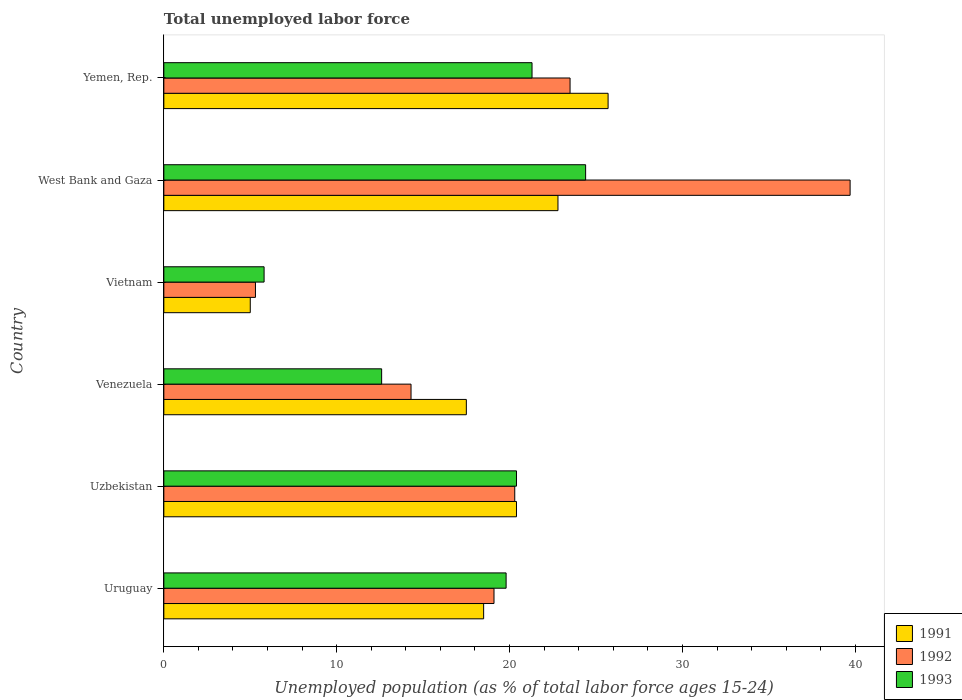How many groups of bars are there?
Make the answer very short. 6. Are the number of bars per tick equal to the number of legend labels?
Offer a terse response. Yes. How many bars are there on the 1st tick from the bottom?
Your response must be concise. 3. What is the label of the 2nd group of bars from the top?
Your response must be concise. West Bank and Gaza. What is the percentage of unemployed population in in 1993 in Vietnam?
Ensure brevity in your answer.  5.8. Across all countries, what is the maximum percentage of unemployed population in in 1992?
Give a very brief answer. 39.7. Across all countries, what is the minimum percentage of unemployed population in in 1992?
Give a very brief answer. 5.3. In which country was the percentage of unemployed population in in 1992 maximum?
Provide a succinct answer. West Bank and Gaza. In which country was the percentage of unemployed population in in 1993 minimum?
Offer a very short reply. Vietnam. What is the total percentage of unemployed population in in 1993 in the graph?
Provide a succinct answer. 104.3. What is the difference between the percentage of unemployed population in in 1991 in Uzbekistan and that in Venezuela?
Provide a succinct answer. 2.9. What is the difference between the percentage of unemployed population in in 1993 in West Bank and Gaza and the percentage of unemployed population in in 1992 in Venezuela?
Provide a short and direct response. 10.1. What is the average percentage of unemployed population in in 1993 per country?
Make the answer very short. 17.38. What is the difference between the percentage of unemployed population in in 1993 and percentage of unemployed population in in 1991 in Uzbekistan?
Make the answer very short. 0. In how many countries, is the percentage of unemployed population in in 1992 greater than 38 %?
Your response must be concise. 1. What is the ratio of the percentage of unemployed population in in 1992 in Vietnam to that in West Bank and Gaza?
Provide a short and direct response. 0.13. Is the percentage of unemployed population in in 1993 in Vietnam less than that in Yemen, Rep.?
Offer a terse response. Yes. What is the difference between the highest and the second highest percentage of unemployed population in in 1991?
Keep it short and to the point. 2.9. What is the difference between the highest and the lowest percentage of unemployed population in in 1991?
Your response must be concise. 20.7. Is the sum of the percentage of unemployed population in in 1992 in Uzbekistan and Vietnam greater than the maximum percentage of unemployed population in in 1991 across all countries?
Give a very brief answer. No. What does the 1st bar from the bottom in Vietnam represents?
Provide a succinct answer. 1991. Is it the case that in every country, the sum of the percentage of unemployed population in in 1993 and percentage of unemployed population in in 1991 is greater than the percentage of unemployed population in in 1992?
Give a very brief answer. Yes. How many bars are there?
Your response must be concise. 18. How many countries are there in the graph?
Ensure brevity in your answer.  6. What is the difference between two consecutive major ticks on the X-axis?
Your answer should be very brief. 10. Are the values on the major ticks of X-axis written in scientific E-notation?
Offer a very short reply. No. Does the graph contain grids?
Your answer should be very brief. No. How many legend labels are there?
Provide a succinct answer. 3. How are the legend labels stacked?
Ensure brevity in your answer.  Vertical. What is the title of the graph?
Provide a succinct answer. Total unemployed labor force. Does "1969" appear as one of the legend labels in the graph?
Make the answer very short. No. What is the label or title of the X-axis?
Provide a succinct answer. Unemployed population (as % of total labor force ages 15-24). What is the Unemployed population (as % of total labor force ages 15-24) of 1991 in Uruguay?
Provide a succinct answer. 18.5. What is the Unemployed population (as % of total labor force ages 15-24) of 1992 in Uruguay?
Offer a terse response. 19.1. What is the Unemployed population (as % of total labor force ages 15-24) in 1993 in Uruguay?
Give a very brief answer. 19.8. What is the Unemployed population (as % of total labor force ages 15-24) in 1991 in Uzbekistan?
Provide a succinct answer. 20.4. What is the Unemployed population (as % of total labor force ages 15-24) in 1992 in Uzbekistan?
Your answer should be very brief. 20.3. What is the Unemployed population (as % of total labor force ages 15-24) in 1993 in Uzbekistan?
Offer a very short reply. 20.4. What is the Unemployed population (as % of total labor force ages 15-24) of 1992 in Venezuela?
Your answer should be compact. 14.3. What is the Unemployed population (as % of total labor force ages 15-24) in 1993 in Venezuela?
Your answer should be very brief. 12.6. What is the Unemployed population (as % of total labor force ages 15-24) of 1991 in Vietnam?
Your answer should be compact. 5. What is the Unemployed population (as % of total labor force ages 15-24) of 1992 in Vietnam?
Your answer should be compact. 5.3. What is the Unemployed population (as % of total labor force ages 15-24) of 1993 in Vietnam?
Your answer should be compact. 5.8. What is the Unemployed population (as % of total labor force ages 15-24) of 1991 in West Bank and Gaza?
Keep it short and to the point. 22.8. What is the Unemployed population (as % of total labor force ages 15-24) of 1992 in West Bank and Gaza?
Your response must be concise. 39.7. What is the Unemployed population (as % of total labor force ages 15-24) of 1993 in West Bank and Gaza?
Ensure brevity in your answer.  24.4. What is the Unemployed population (as % of total labor force ages 15-24) of 1991 in Yemen, Rep.?
Offer a terse response. 25.7. What is the Unemployed population (as % of total labor force ages 15-24) of 1993 in Yemen, Rep.?
Keep it short and to the point. 21.3. Across all countries, what is the maximum Unemployed population (as % of total labor force ages 15-24) of 1991?
Ensure brevity in your answer.  25.7. Across all countries, what is the maximum Unemployed population (as % of total labor force ages 15-24) in 1992?
Provide a short and direct response. 39.7. Across all countries, what is the maximum Unemployed population (as % of total labor force ages 15-24) in 1993?
Ensure brevity in your answer.  24.4. Across all countries, what is the minimum Unemployed population (as % of total labor force ages 15-24) of 1991?
Provide a succinct answer. 5. Across all countries, what is the minimum Unemployed population (as % of total labor force ages 15-24) in 1992?
Provide a short and direct response. 5.3. Across all countries, what is the minimum Unemployed population (as % of total labor force ages 15-24) in 1993?
Offer a terse response. 5.8. What is the total Unemployed population (as % of total labor force ages 15-24) of 1991 in the graph?
Ensure brevity in your answer.  109.9. What is the total Unemployed population (as % of total labor force ages 15-24) of 1992 in the graph?
Your answer should be very brief. 122.2. What is the total Unemployed population (as % of total labor force ages 15-24) in 1993 in the graph?
Offer a terse response. 104.3. What is the difference between the Unemployed population (as % of total labor force ages 15-24) of 1991 in Uruguay and that in Uzbekistan?
Offer a terse response. -1.9. What is the difference between the Unemployed population (as % of total labor force ages 15-24) in 1992 in Uruguay and that in Uzbekistan?
Your response must be concise. -1.2. What is the difference between the Unemployed population (as % of total labor force ages 15-24) of 1991 in Uruguay and that in Venezuela?
Give a very brief answer. 1. What is the difference between the Unemployed population (as % of total labor force ages 15-24) in 1992 in Uruguay and that in Venezuela?
Provide a short and direct response. 4.8. What is the difference between the Unemployed population (as % of total labor force ages 15-24) of 1991 in Uruguay and that in Vietnam?
Keep it short and to the point. 13.5. What is the difference between the Unemployed population (as % of total labor force ages 15-24) in 1992 in Uruguay and that in Vietnam?
Make the answer very short. 13.8. What is the difference between the Unemployed population (as % of total labor force ages 15-24) in 1993 in Uruguay and that in Vietnam?
Offer a very short reply. 14. What is the difference between the Unemployed population (as % of total labor force ages 15-24) in 1991 in Uruguay and that in West Bank and Gaza?
Provide a succinct answer. -4.3. What is the difference between the Unemployed population (as % of total labor force ages 15-24) of 1992 in Uruguay and that in West Bank and Gaza?
Keep it short and to the point. -20.6. What is the difference between the Unemployed population (as % of total labor force ages 15-24) in 1993 in Uruguay and that in West Bank and Gaza?
Keep it short and to the point. -4.6. What is the difference between the Unemployed population (as % of total labor force ages 15-24) of 1991 in Uzbekistan and that in West Bank and Gaza?
Provide a short and direct response. -2.4. What is the difference between the Unemployed population (as % of total labor force ages 15-24) of 1992 in Uzbekistan and that in West Bank and Gaza?
Ensure brevity in your answer.  -19.4. What is the difference between the Unemployed population (as % of total labor force ages 15-24) of 1993 in Uzbekistan and that in West Bank and Gaza?
Make the answer very short. -4. What is the difference between the Unemployed population (as % of total labor force ages 15-24) in 1992 in Uzbekistan and that in Yemen, Rep.?
Provide a succinct answer. -3.2. What is the difference between the Unemployed population (as % of total labor force ages 15-24) of 1993 in Uzbekistan and that in Yemen, Rep.?
Ensure brevity in your answer.  -0.9. What is the difference between the Unemployed population (as % of total labor force ages 15-24) in 1992 in Venezuela and that in Vietnam?
Offer a terse response. 9. What is the difference between the Unemployed population (as % of total labor force ages 15-24) of 1991 in Venezuela and that in West Bank and Gaza?
Keep it short and to the point. -5.3. What is the difference between the Unemployed population (as % of total labor force ages 15-24) of 1992 in Venezuela and that in West Bank and Gaza?
Offer a very short reply. -25.4. What is the difference between the Unemployed population (as % of total labor force ages 15-24) in 1993 in Venezuela and that in West Bank and Gaza?
Offer a terse response. -11.8. What is the difference between the Unemployed population (as % of total labor force ages 15-24) of 1992 in Venezuela and that in Yemen, Rep.?
Your answer should be very brief. -9.2. What is the difference between the Unemployed population (as % of total labor force ages 15-24) of 1991 in Vietnam and that in West Bank and Gaza?
Offer a very short reply. -17.8. What is the difference between the Unemployed population (as % of total labor force ages 15-24) of 1992 in Vietnam and that in West Bank and Gaza?
Your answer should be compact. -34.4. What is the difference between the Unemployed population (as % of total labor force ages 15-24) of 1993 in Vietnam and that in West Bank and Gaza?
Make the answer very short. -18.6. What is the difference between the Unemployed population (as % of total labor force ages 15-24) in 1991 in Vietnam and that in Yemen, Rep.?
Your answer should be compact. -20.7. What is the difference between the Unemployed population (as % of total labor force ages 15-24) in 1992 in Vietnam and that in Yemen, Rep.?
Give a very brief answer. -18.2. What is the difference between the Unemployed population (as % of total labor force ages 15-24) of 1993 in Vietnam and that in Yemen, Rep.?
Keep it short and to the point. -15.5. What is the difference between the Unemployed population (as % of total labor force ages 15-24) in 1991 in West Bank and Gaza and that in Yemen, Rep.?
Offer a very short reply. -2.9. What is the difference between the Unemployed population (as % of total labor force ages 15-24) in 1992 in West Bank and Gaza and that in Yemen, Rep.?
Your response must be concise. 16.2. What is the difference between the Unemployed population (as % of total labor force ages 15-24) in 1993 in West Bank and Gaza and that in Yemen, Rep.?
Your answer should be compact. 3.1. What is the difference between the Unemployed population (as % of total labor force ages 15-24) in 1991 in Uruguay and the Unemployed population (as % of total labor force ages 15-24) in 1993 in Uzbekistan?
Provide a short and direct response. -1.9. What is the difference between the Unemployed population (as % of total labor force ages 15-24) of 1992 in Uruguay and the Unemployed population (as % of total labor force ages 15-24) of 1993 in Uzbekistan?
Your response must be concise. -1.3. What is the difference between the Unemployed population (as % of total labor force ages 15-24) of 1991 in Uruguay and the Unemployed population (as % of total labor force ages 15-24) of 1992 in Venezuela?
Make the answer very short. 4.2. What is the difference between the Unemployed population (as % of total labor force ages 15-24) in 1992 in Uruguay and the Unemployed population (as % of total labor force ages 15-24) in 1993 in Venezuela?
Give a very brief answer. 6.5. What is the difference between the Unemployed population (as % of total labor force ages 15-24) of 1991 in Uruguay and the Unemployed population (as % of total labor force ages 15-24) of 1992 in Vietnam?
Your answer should be very brief. 13.2. What is the difference between the Unemployed population (as % of total labor force ages 15-24) of 1991 in Uruguay and the Unemployed population (as % of total labor force ages 15-24) of 1993 in Vietnam?
Offer a very short reply. 12.7. What is the difference between the Unemployed population (as % of total labor force ages 15-24) of 1991 in Uruguay and the Unemployed population (as % of total labor force ages 15-24) of 1992 in West Bank and Gaza?
Your answer should be compact. -21.2. What is the difference between the Unemployed population (as % of total labor force ages 15-24) in 1991 in Uruguay and the Unemployed population (as % of total labor force ages 15-24) in 1992 in Yemen, Rep.?
Offer a terse response. -5. What is the difference between the Unemployed population (as % of total labor force ages 15-24) of 1992 in Uruguay and the Unemployed population (as % of total labor force ages 15-24) of 1993 in Yemen, Rep.?
Provide a succinct answer. -2.2. What is the difference between the Unemployed population (as % of total labor force ages 15-24) in 1991 in Uzbekistan and the Unemployed population (as % of total labor force ages 15-24) in 1992 in Vietnam?
Provide a succinct answer. 15.1. What is the difference between the Unemployed population (as % of total labor force ages 15-24) of 1991 in Uzbekistan and the Unemployed population (as % of total labor force ages 15-24) of 1993 in Vietnam?
Ensure brevity in your answer.  14.6. What is the difference between the Unemployed population (as % of total labor force ages 15-24) of 1991 in Uzbekistan and the Unemployed population (as % of total labor force ages 15-24) of 1992 in West Bank and Gaza?
Provide a short and direct response. -19.3. What is the difference between the Unemployed population (as % of total labor force ages 15-24) of 1991 in Uzbekistan and the Unemployed population (as % of total labor force ages 15-24) of 1993 in West Bank and Gaza?
Provide a short and direct response. -4. What is the difference between the Unemployed population (as % of total labor force ages 15-24) of 1991 in Uzbekistan and the Unemployed population (as % of total labor force ages 15-24) of 1993 in Yemen, Rep.?
Your answer should be very brief. -0.9. What is the difference between the Unemployed population (as % of total labor force ages 15-24) of 1992 in Uzbekistan and the Unemployed population (as % of total labor force ages 15-24) of 1993 in Yemen, Rep.?
Your answer should be compact. -1. What is the difference between the Unemployed population (as % of total labor force ages 15-24) of 1992 in Venezuela and the Unemployed population (as % of total labor force ages 15-24) of 1993 in Vietnam?
Ensure brevity in your answer.  8.5. What is the difference between the Unemployed population (as % of total labor force ages 15-24) of 1991 in Venezuela and the Unemployed population (as % of total labor force ages 15-24) of 1992 in West Bank and Gaza?
Provide a short and direct response. -22.2. What is the difference between the Unemployed population (as % of total labor force ages 15-24) in 1991 in Venezuela and the Unemployed population (as % of total labor force ages 15-24) in 1993 in West Bank and Gaza?
Provide a succinct answer. -6.9. What is the difference between the Unemployed population (as % of total labor force ages 15-24) in 1992 in Venezuela and the Unemployed population (as % of total labor force ages 15-24) in 1993 in West Bank and Gaza?
Ensure brevity in your answer.  -10.1. What is the difference between the Unemployed population (as % of total labor force ages 15-24) in 1991 in Vietnam and the Unemployed population (as % of total labor force ages 15-24) in 1992 in West Bank and Gaza?
Offer a very short reply. -34.7. What is the difference between the Unemployed population (as % of total labor force ages 15-24) of 1991 in Vietnam and the Unemployed population (as % of total labor force ages 15-24) of 1993 in West Bank and Gaza?
Your answer should be very brief. -19.4. What is the difference between the Unemployed population (as % of total labor force ages 15-24) in 1992 in Vietnam and the Unemployed population (as % of total labor force ages 15-24) in 1993 in West Bank and Gaza?
Give a very brief answer. -19.1. What is the difference between the Unemployed population (as % of total labor force ages 15-24) of 1991 in Vietnam and the Unemployed population (as % of total labor force ages 15-24) of 1992 in Yemen, Rep.?
Give a very brief answer. -18.5. What is the difference between the Unemployed population (as % of total labor force ages 15-24) in 1991 in Vietnam and the Unemployed population (as % of total labor force ages 15-24) in 1993 in Yemen, Rep.?
Ensure brevity in your answer.  -16.3. What is the difference between the Unemployed population (as % of total labor force ages 15-24) of 1991 in West Bank and Gaza and the Unemployed population (as % of total labor force ages 15-24) of 1992 in Yemen, Rep.?
Your answer should be very brief. -0.7. What is the difference between the Unemployed population (as % of total labor force ages 15-24) of 1991 in West Bank and Gaza and the Unemployed population (as % of total labor force ages 15-24) of 1993 in Yemen, Rep.?
Ensure brevity in your answer.  1.5. What is the average Unemployed population (as % of total labor force ages 15-24) of 1991 per country?
Provide a succinct answer. 18.32. What is the average Unemployed population (as % of total labor force ages 15-24) of 1992 per country?
Make the answer very short. 20.37. What is the average Unemployed population (as % of total labor force ages 15-24) of 1993 per country?
Make the answer very short. 17.38. What is the difference between the Unemployed population (as % of total labor force ages 15-24) in 1991 and Unemployed population (as % of total labor force ages 15-24) in 1993 in Uruguay?
Make the answer very short. -1.3. What is the difference between the Unemployed population (as % of total labor force ages 15-24) in 1992 and Unemployed population (as % of total labor force ages 15-24) in 1993 in Uruguay?
Offer a terse response. -0.7. What is the difference between the Unemployed population (as % of total labor force ages 15-24) of 1991 and Unemployed population (as % of total labor force ages 15-24) of 1992 in Venezuela?
Give a very brief answer. 3.2. What is the difference between the Unemployed population (as % of total labor force ages 15-24) in 1991 and Unemployed population (as % of total labor force ages 15-24) in 1993 in Venezuela?
Ensure brevity in your answer.  4.9. What is the difference between the Unemployed population (as % of total labor force ages 15-24) of 1991 and Unemployed population (as % of total labor force ages 15-24) of 1992 in Vietnam?
Ensure brevity in your answer.  -0.3. What is the difference between the Unemployed population (as % of total labor force ages 15-24) of 1991 and Unemployed population (as % of total labor force ages 15-24) of 1993 in Vietnam?
Provide a succinct answer. -0.8. What is the difference between the Unemployed population (as % of total labor force ages 15-24) in 1992 and Unemployed population (as % of total labor force ages 15-24) in 1993 in Vietnam?
Your answer should be very brief. -0.5. What is the difference between the Unemployed population (as % of total labor force ages 15-24) in 1991 and Unemployed population (as % of total labor force ages 15-24) in 1992 in West Bank and Gaza?
Keep it short and to the point. -16.9. What is the difference between the Unemployed population (as % of total labor force ages 15-24) in 1991 and Unemployed population (as % of total labor force ages 15-24) in 1992 in Yemen, Rep.?
Offer a very short reply. 2.2. What is the ratio of the Unemployed population (as % of total labor force ages 15-24) in 1991 in Uruguay to that in Uzbekistan?
Provide a succinct answer. 0.91. What is the ratio of the Unemployed population (as % of total labor force ages 15-24) of 1992 in Uruguay to that in Uzbekistan?
Keep it short and to the point. 0.94. What is the ratio of the Unemployed population (as % of total labor force ages 15-24) of 1993 in Uruguay to that in Uzbekistan?
Ensure brevity in your answer.  0.97. What is the ratio of the Unemployed population (as % of total labor force ages 15-24) in 1991 in Uruguay to that in Venezuela?
Keep it short and to the point. 1.06. What is the ratio of the Unemployed population (as % of total labor force ages 15-24) of 1992 in Uruguay to that in Venezuela?
Your answer should be very brief. 1.34. What is the ratio of the Unemployed population (as % of total labor force ages 15-24) of 1993 in Uruguay to that in Venezuela?
Ensure brevity in your answer.  1.57. What is the ratio of the Unemployed population (as % of total labor force ages 15-24) in 1991 in Uruguay to that in Vietnam?
Provide a succinct answer. 3.7. What is the ratio of the Unemployed population (as % of total labor force ages 15-24) in 1992 in Uruguay to that in Vietnam?
Provide a succinct answer. 3.6. What is the ratio of the Unemployed population (as % of total labor force ages 15-24) in 1993 in Uruguay to that in Vietnam?
Your response must be concise. 3.41. What is the ratio of the Unemployed population (as % of total labor force ages 15-24) in 1991 in Uruguay to that in West Bank and Gaza?
Give a very brief answer. 0.81. What is the ratio of the Unemployed population (as % of total labor force ages 15-24) in 1992 in Uruguay to that in West Bank and Gaza?
Provide a short and direct response. 0.48. What is the ratio of the Unemployed population (as % of total labor force ages 15-24) of 1993 in Uruguay to that in West Bank and Gaza?
Provide a short and direct response. 0.81. What is the ratio of the Unemployed population (as % of total labor force ages 15-24) of 1991 in Uruguay to that in Yemen, Rep.?
Your answer should be very brief. 0.72. What is the ratio of the Unemployed population (as % of total labor force ages 15-24) in 1992 in Uruguay to that in Yemen, Rep.?
Keep it short and to the point. 0.81. What is the ratio of the Unemployed population (as % of total labor force ages 15-24) in 1993 in Uruguay to that in Yemen, Rep.?
Provide a short and direct response. 0.93. What is the ratio of the Unemployed population (as % of total labor force ages 15-24) in 1991 in Uzbekistan to that in Venezuela?
Your answer should be compact. 1.17. What is the ratio of the Unemployed population (as % of total labor force ages 15-24) in 1992 in Uzbekistan to that in Venezuela?
Ensure brevity in your answer.  1.42. What is the ratio of the Unemployed population (as % of total labor force ages 15-24) in 1993 in Uzbekistan to that in Venezuela?
Offer a terse response. 1.62. What is the ratio of the Unemployed population (as % of total labor force ages 15-24) of 1991 in Uzbekistan to that in Vietnam?
Offer a very short reply. 4.08. What is the ratio of the Unemployed population (as % of total labor force ages 15-24) of 1992 in Uzbekistan to that in Vietnam?
Offer a terse response. 3.83. What is the ratio of the Unemployed population (as % of total labor force ages 15-24) in 1993 in Uzbekistan to that in Vietnam?
Your answer should be compact. 3.52. What is the ratio of the Unemployed population (as % of total labor force ages 15-24) in 1991 in Uzbekistan to that in West Bank and Gaza?
Give a very brief answer. 0.89. What is the ratio of the Unemployed population (as % of total labor force ages 15-24) in 1992 in Uzbekistan to that in West Bank and Gaza?
Provide a short and direct response. 0.51. What is the ratio of the Unemployed population (as % of total labor force ages 15-24) of 1993 in Uzbekistan to that in West Bank and Gaza?
Offer a very short reply. 0.84. What is the ratio of the Unemployed population (as % of total labor force ages 15-24) of 1991 in Uzbekistan to that in Yemen, Rep.?
Provide a succinct answer. 0.79. What is the ratio of the Unemployed population (as % of total labor force ages 15-24) in 1992 in Uzbekistan to that in Yemen, Rep.?
Make the answer very short. 0.86. What is the ratio of the Unemployed population (as % of total labor force ages 15-24) of 1993 in Uzbekistan to that in Yemen, Rep.?
Ensure brevity in your answer.  0.96. What is the ratio of the Unemployed population (as % of total labor force ages 15-24) of 1992 in Venezuela to that in Vietnam?
Ensure brevity in your answer.  2.7. What is the ratio of the Unemployed population (as % of total labor force ages 15-24) of 1993 in Venezuela to that in Vietnam?
Make the answer very short. 2.17. What is the ratio of the Unemployed population (as % of total labor force ages 15-24) of 1991 in Venezuela to that in West Bank and Gaza?
Give a very brief answer. 0.77. What is the ratio of the Unemployed population (as % of total labor force ages 15-24) in 1992 in Venezuela to that in West Bank and Gaza?
Provide a succinct answer. 0.36. What is the ratio of the Unemployed population (as % of total labor force ages 15-24) in 1993 in Venezuela to that in West Bank and Gaza?
Provide a succinct answer. 0.52. What is the ratio of the Unemployed population (as % of total labor force ages 15-24) of 1991 in Venezuela to that in Yemen, Rep.?
Provide a succinct answer. 0.68. What is the ratio of the Unemployed population (as % of total labor force ages 15-24) of 1992 in Venezuela to that in Yemen, Rep.?
Offer a terse response. 0.61. What is the ratio of the Unemployed population (as % of total labor force ages 15-24) of 1993 in Venezuela to that in Yemen, Rep.?
Offer a terse response. 0.59. What is the ratio of the Unemployed population (as % of total labor force ages 15-24) in 1991 in Vietnam to that in West Bank and Gaza?
Give a very brief answer. 0.22. What is the ratio of the Unemployed population (as % of total labor force ages 15-24) in 1992 in Vietnam to that in West Bank and Gaza?
Offer a terse response. 0.13. What is the ratio of the Unemployed population (as % of total labor force ages 15-24) of 1993 in Vietnam to that in West Bank and Gaza?
Keep it short and to the point. 0.24. What is the ratio of the Unemployed population (as % of total labor force ages 15-24) in 1991 in Vietnam to that in Yemen, Rep.?
Provide a short and direct response. 0.19. What is the ratio of the Unemployed population (as % of total labor force ages 15-24) in 1992 in Vietnam to that in Yemen, Rep.?
Provide a short and direct response. 0.23. What is the ratio of the Unemployed population (as % of total labor force ages 15-24) of 1993 in Vietnam to that in Yemen, Rep.?
Your answer should be compact. 0.27. What is the ratio of the Unemployed population (as % of total labor force ages 15-24) in 1991 in West Bank and Gaza to that in Yemen, Rep.?
Make the answer very short. 0.89. What is the ratio of the Unemployed population (as % of total labor force ages 15-24) in 1992 in West Bank and Gaza to that in Yemen, Rep.?
Offer a terse response. 1.69. What is the ratio of the Unemployed population (as % of total labor force ages 15-24) in 1993 in West Bank and Gaza to that in Yemen, Rep.?
Your answer should be very brief. 1.15. What is the difference between the highest and the second highest Unemployed population (as % of total labor force ages 15-24) in 1991?
Your answer should be very brief. 2.9. What is the difference between the highest and the second highest Unemployed population (as % of total labor force ages 15-24) in 1992?
Provide a succinct answer. 16.2. What is the difference between the highest and the second highest Unemployed population (as % of total labor force ages 15-24) in 1993?
Give a very brief answer. 3.1. What is the difference between the highest and the lowest Unemployed population (as % of total labor force ages 15-24) of 1991?
Ensure brevity in your answer.  20.7. What is the difference between the highest and the lowest Unemployed population (as % of total labor force ages 15-24) of 1992?
Provide a short and direct response. 34.4. What is the difference between the highest and the lowest Unemployed population (as % of total labor force ages 15-24) of 1993?
Give a very brief answer. 18.6. 